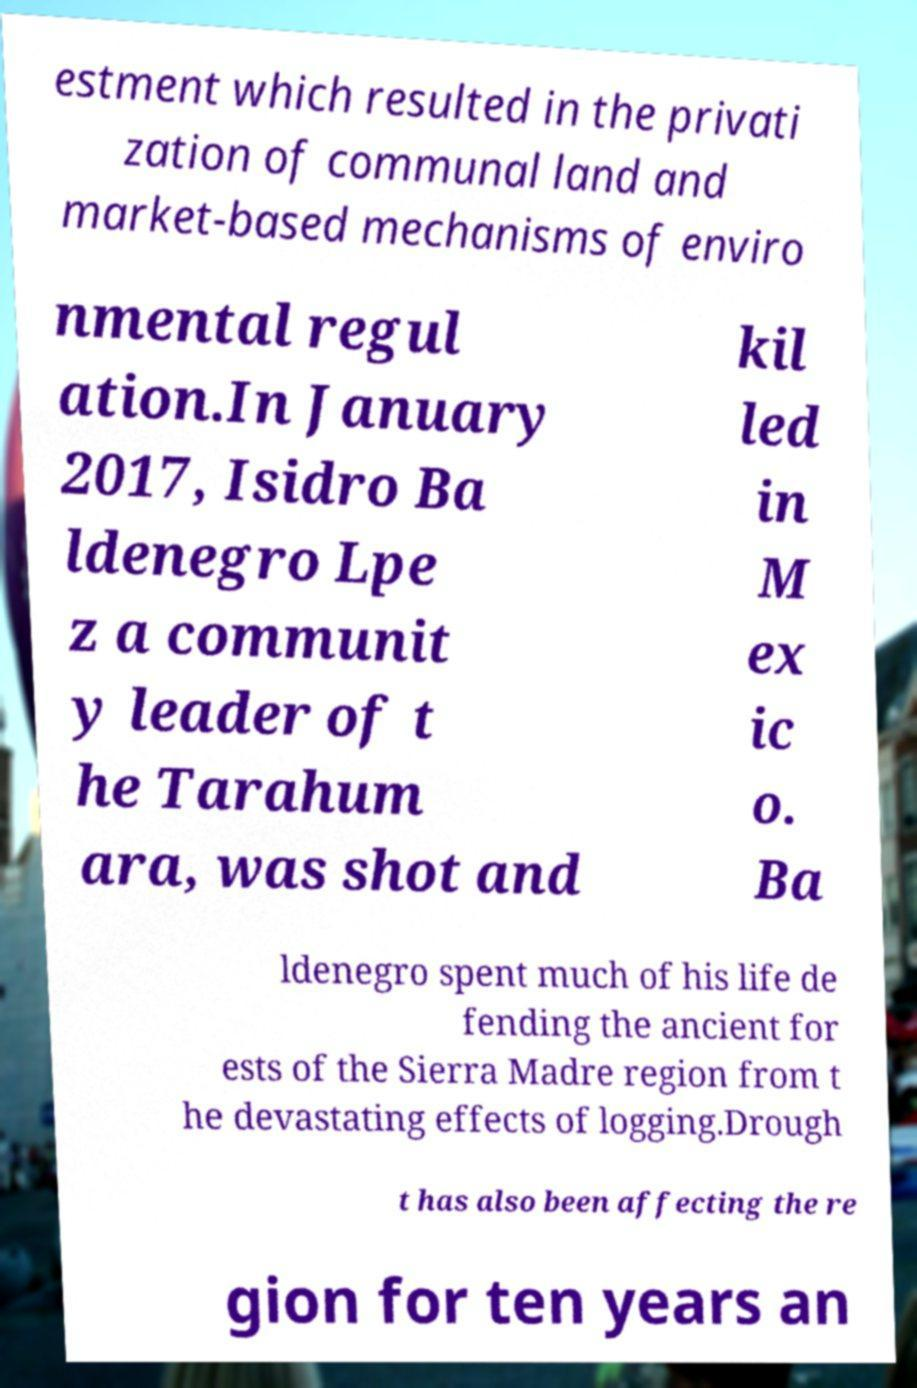I need the written content from this picture converted into text. Can you do that? estment which resulted in the privati zation of communal land and market-based mechanisms of enviro nmental regul ation.In January 2017, Isidro Ba ldenegro Lpe z a communit y leader of t he Tarahum ara, was shot and kil led in M ex ic o. Ba ldenegro spent much of his life de fending the ancient for ests of the Sierra Madre region from t he devastating effects of logging.Drough t has also been affecting the re gion for ten years an 